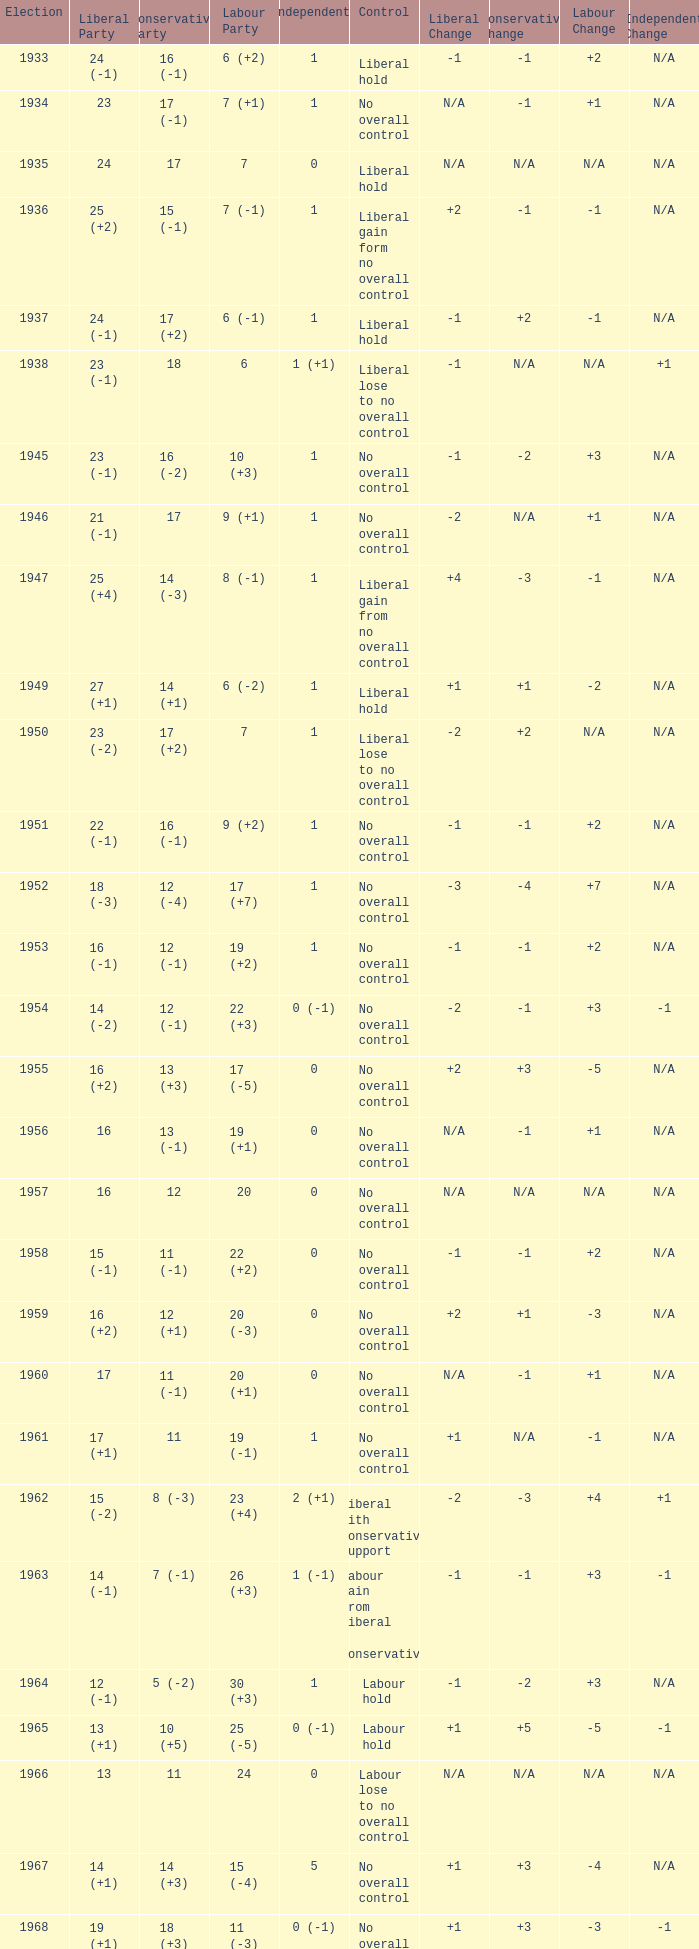Could you parse the entire table as a dict? {'header': ['Election', 'Liberal Party', 'Conservative Party', 'Labour Party', 'Independents', 'Control', 'Liberal Change', 'Conservative Change', 'Labour Change', 'Independent Change'], 'rows': [['1933', '24 (-1)', '16 (-1)', '6 (+2)', '1', 'Liberal hold', '-1', '-1', '+2', 'N/A'], ['1934', '23', '17 (-1)', '7 (+1)', '1', 'No overall control', 'N/A', '-1', '+1', 'N/A'], ['1935', '24', '17', '7', '0', 'Liberal hold', 'N/A', 'N/A', 'N/A', 'N/A'], ['1936', '25 (+2)', '15 (-1)', '7 (-1)', '1', 'Liberal gain form no overall control', '+2', '-1', '-1', 'N/A'], ['1937', '24 (-1)', '17 (+2)', '6 (-1)', '1', 'Liberal hold', '-1', '+2', '-1', 'N/A'], ['1938', '23 (-1)', '18', '6', '1 (+1)', 'Liberal lose to no overall control', '-1', 'N/A', 'N/A', '+1'], ['1945', '23 (-1)', '16 (-2)', '10 (+3)', '1', 'No overall control', '-1', '-2', '+3', 'N/A'], ['1946', '21 (-1)', '17', '9 (+1)', '1', 'No overall control', '-2', 'N/A', '+1', 'N/A'], ['1947', '25 (+4)', '14 (-3)', '8 (-1)', '1', 'Liberal gain from no overall control', '+4', '-3', '-1', 'N/A'], ['1949', '27 (+1)', '14 (+1)', '6 (-2)', '1', 'Liberal hold', '+1', '+1', '-2', 'N/A'], ['1950', '23 (-2)', '17 (+2)', '7', '1', 'Liberal lose to no overall control', '-2', '+2', 'N/A', 'N/A'], ['1951', '22 (-1)', '16 (-1)', '9 (+2)', '1', 'No overall control', '-1', '-1', '+2', 'N/A'], ['1952', '18 (-3)', '12 (-4)', '17 (+7)', '1', 'No overall control', '-3', '-4', '+7', 'N/A'], ['1953', '16 (-1)', '12 (-1)', '19 (+2)', '1', 'No overall control', '-1', '-1', '+2', 'N/A'], ['1954', '14 (-2)', '12 (-1)', '22 (+3)', '0 (-1)', 'No overall control', '-2', '-1', '+3', '-1'], ['1955', '16 (+2)', '13 (+3)', '17 (-5)', '0', 'No overall control', '+2', '+3', '-5', 'N/A'], ['1956', '16', '13 (-1)', '19 (+1)', '0', 'No overall control', 'N/A', '-1', '+1', 'N/A'], ['1957', '16', '12', '20', '0', 'No overall control', 'N/A', 'N/A', 'N/A', 'N/A'], ['1958', '15 (-1)', '11 (-1)', '22 (+2)', '0', 'No overall control', '-1', '-1', '+2', 'N/A'], ['1959', '16 (+2)', '12 (+1)', '20 (-3)', '0', 'No overall control', '+2', '+1', '-3', 'N/A'], ['1960', '17', '11 (-1)', '20 (+1)', '0', 'No overall control', 'N/A', '-1', '+1', 'N/A'], ['1961', '17 (+1)', '11', '19 (-1)', '1', 'No overall control', '+1', 'N/A', '-1', 'N/A'], ['1962', '15 (-2)', '8 (-3)', '23 (+4)', '2 (+1)', 'Liberal with Conservative support', '-2', '-3', '+4', '+1'], ['1963', '14 (-1)', '7 (-1)', '26 (+3)', '1 (-1)', 'Labour gain from Liberal - Conservative', '-1', '-1', '+3', '-1'], ['1964', '12 (-1)', '5 (-2)', '30 (+3)', '1', 'Labour hold', '-1', '-2', '+3', 'N/A'], ['1965', '13 (+1)', '10 (+5)', '25 (-5)', '0 (-1)', 'Labour hold', '+1', '+5', '-5', '-1'], ['1966', '13', '11', '24', '0', 'Labour lose to no overall control', 'N/A', 'N/A', 'N/A', 'N/A'], ['1967', '14 (+1)', '14 (+3)', '15 (-4)', '5', 'No overall control', '+1', '+3', '-4', 'N/A'], ['1968', '19 (+1)', '18 (+3)', '11 (-3)', '0 (-1)', 'No overall control', '+1', '+3', '-3', '-1'], ['1969', '20 (+1)', '21 (+3)', '7 (-4)', '0', 'No overall control', '+1', '+3', '-4', 'N/A'], ['1970', '15 (-2)', '19 (-4)', '12 (+6)', '1', 'No overall control (1 vacancy)', '-2', '-4', '+6', 'N/A'], ['1971', '11 (-2)', '14 (-5)', '22 (+7)', '1', 'No overall control', '-2', '-5', '+7', 'N/A'], ['1972', '9 (-4)', '11 (-1)', '28 (+6)', '0 (-1)', 'Labour gain from no overall control', '-4', '-1', '+6', '-1']]} What was the control for the year with a Conservative Party result of 10 (+5)? Labour hold. 